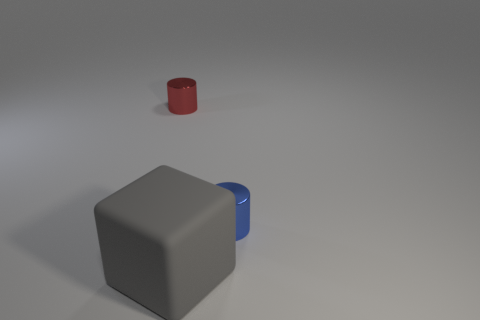Is the red cylinder behind the blue thing made of the same material as the blue cylinder?
Ensure brevity in your answer.  Yes. There is a metallic cylinder to the right of the tiny object left of the tiny shiny object in front of the small red metallic cylinder; what size is it?
Provide a succinct answer. Small. How many other things are the same color as the rubber cube?
Your answer should be very brief. 0. What shape is the thing that is the same size as the red cylinder?
Offer a terse response. Cylinder. What is the size of the metal cylinder that is in front of the tiny red thing?
Your answer should be very brief. Small. Do the tiny object that is to the left of the gray thing and the tiny shiny cylinder that is on the right side of the gray object have the same color?
Offer a terse response. No. What is the material of the cylinder on the left side of the gray object on the left side of the cylinder in front of the red shiny cylinder?
Your answer should be very brief. Metal. Is there another blue shiny cylinder of the same size as the blue metal cylinder?
Your answer should be compact. No. What is the material of the other thing that is the same size as the red object?
Give a very brief answer. Metal. There is a large gray matte thing in front of the tiny red metal thing; what is its shape?
Your answer should be very brief. Cube. 